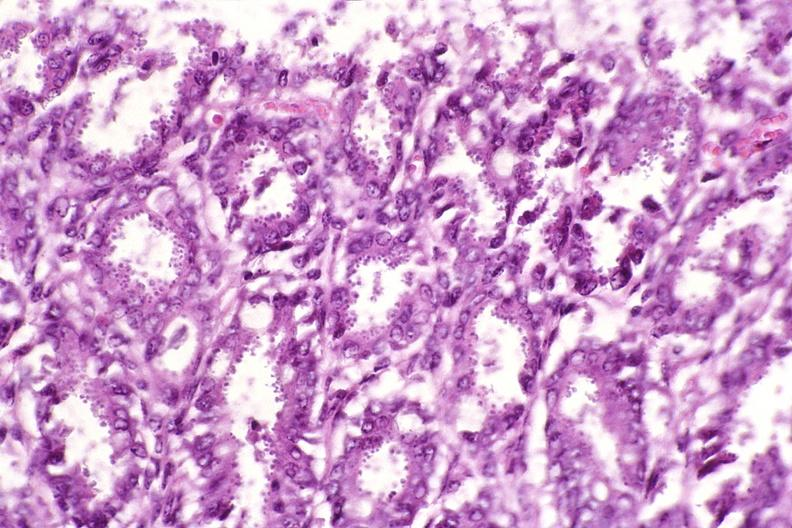does this image show colon, cryptosporidia?
Answer the question using a single word or phrase. Yes 